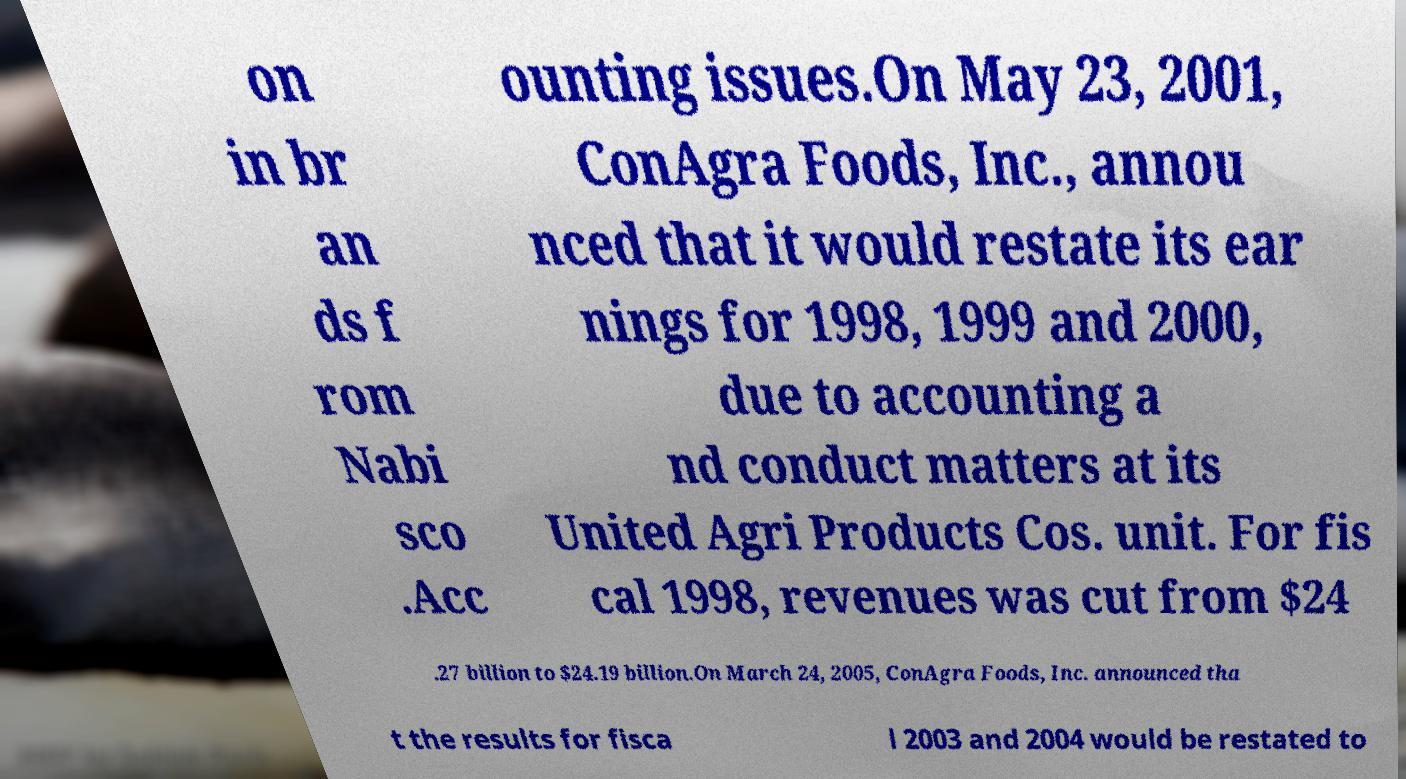I need the written content from this picture converted into text. Can you do that? on in br an ds f rom Nabi sco .Acc ounting issues.On May 23, 2001, ConAgra Foods, Inc., annou nced that it would restate its ear nings for 1998, 1999 and 2000, due to accounting a nd conduct matters at its United Agri Products Cos. unit. For fis cal 1998, revenues was cut from $24 .27 billion to $24.19 billion.On March 24, 2005, ConAgra Foods, Inc. announced tha t the results for fisca l 2003 and 2004 would be restated to 